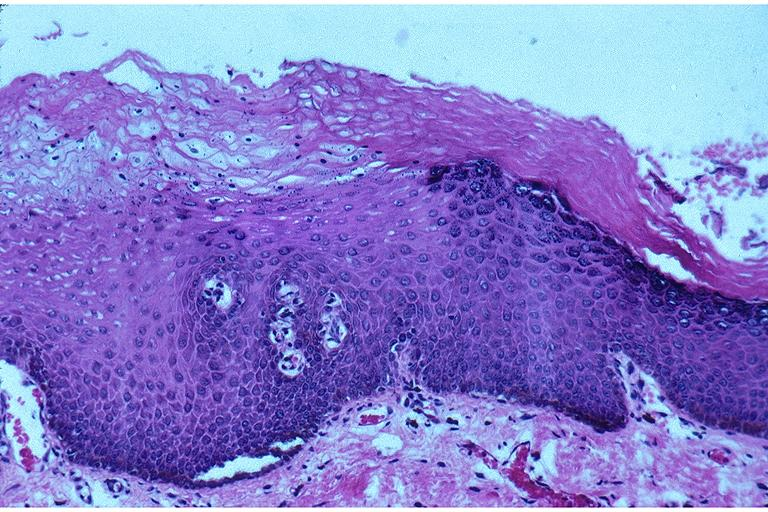s metastatic colon cancer present?
Answer the question using a single word or phrase. No 